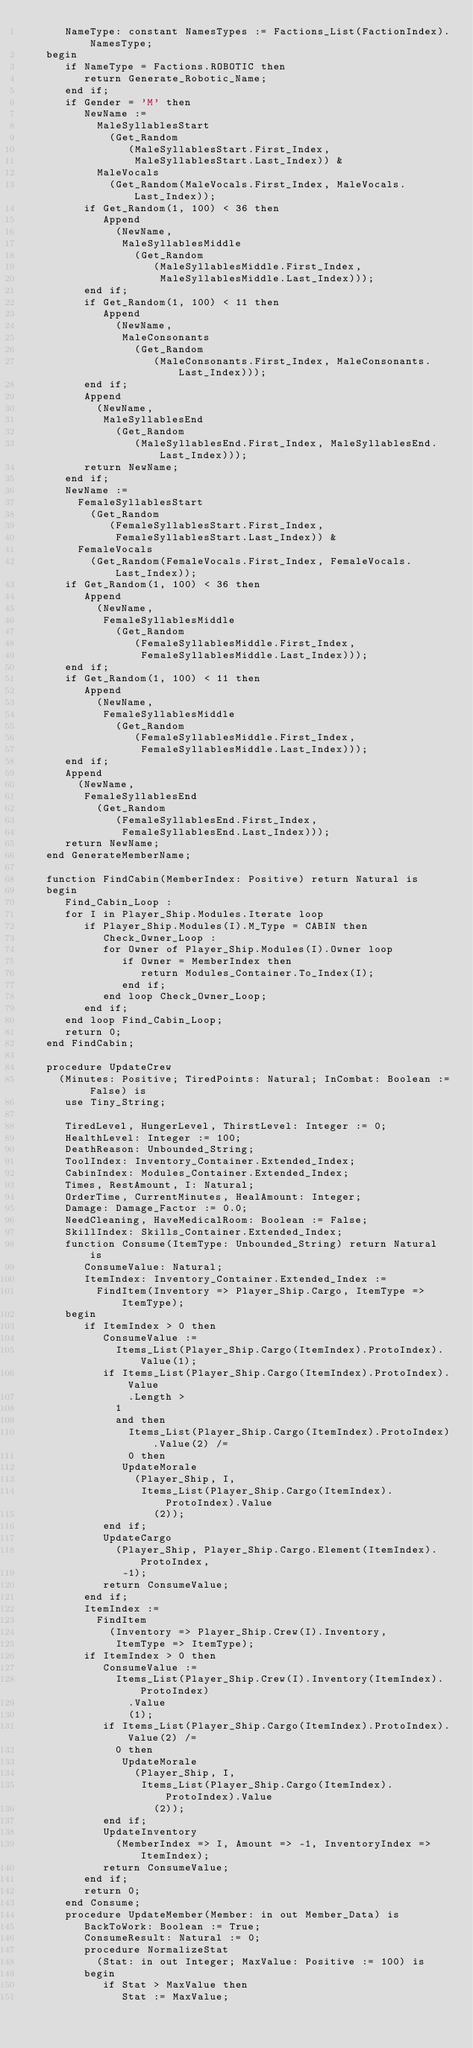Convert code to text. <code><loc_0><loc_0><loc_500><loc_500><_Ada_>      NameType: constant NamesTypes := Factions_List(FactionIndex).NamesType;
   begin
      if NameType = Factions.ROBOTIC then
         return Generate_Robotic_Name;
      end if;
      if Gender = 'M' then
         NewName :=
           MaleSyllablesStart
             (Get_Random
                (MaleSyllablesStart.First_Index,
                 MaleSyllablesStart.Last_Index)) &
           MaleVocals
             (Get_Random(MaleVocals.First_Index, MaleVocals.Last_Index));
         if Get_Random(1, 100) < 36 then
            Append
              (NewName,
               MaleSyllablesMiddle
                 (Get_Random
                    (MaleSyllablesMiddle.First_Index,
                     MaleSyllablesMiddle.Last_Index)));
         end if;
         if Get_Random(1, 100) < 11 then
            Append
              (NewName,
               MaleConsonants
                 (Get_Random
                    (MaleConsonants.First_Index, MaleConsonants.Last_Index)));
         end if;
         Append
           (NewName,
            MaleSyllablesEnd
              (Get_Random
                 (MaleSyllablesEnd.First_Index, MaleSyllablesEnd.Last_Index)));
         return NewName;
      end if;
      NewName :=
        FemaleSyllablesStart
          (Get_Random
             (FemaleSyllablesStart.First_Index,
              FemaleSyllablesStart.Last_Index)) &
        FemaleVocals
          (Get_Random(FemaleVocals.First_Index, FemaleVocals.Last_Index));
      if Get_Random(1, 100) < 36 then
         Append
           (NewName,
            FemaleSyllablesMiddle
              (Get_Random
                 (FemaleSyllablesMiddle.First_Index,
                  FemaleSyllablesMiddle.Last_Index)));
      end if;
      if Get_Random(1, 100) < 11 then
         Append
           (NewName,
            FemaleSyllablesMiddle
              (Get_Random
                 (FemaleSyllablesMiddle.First_Index,
                  FemaleSyllablesMiddle.Last_Index)));
      end if;
      Append
        (NewName,
         FemaleSyllablesEnd
           (Get_Random
              (FemaleSyllablesEnd.First_Index,
               FemaleSyllablesEnd.Last_Index)));
      return NewName;
   end GenerateMemberName;

   function FindCabin(MemberIndex: Positive) return Natural is
   begin
      Find_Cabin_Loop :
      for I in Player_Ship.Modules.Iterate loop
         if Player_Ship.Modules(I).M_Type = CABIN then
            Check_Owner_Loop :
            for Owner of Player_Ship.Modules(I).Owner loop
               if Owner = MemberIndex then
                  return Modules_Container.To_Index(I);
               end if;
            end loop Check_Owner_Loop;
         end if;
      end loop Find_Cabin_Loop;
      return 0;
   end FindCabin;

   procedure UpdateCrew
     (Minutes: Positive; TiredPoints: Natural; InCombat: Boolean := False) is
      use Tiny_String;

      TiredLevel, HungerLevel, ThirstLevel: Integer := 0;
      HealthLevel: Integer := 100;
      DeathReason: Unbounded_String;
      ToolIndex: Inventory_Container.Extended_Index;
      CabinIndex: Modules_Container.Extended_Index;
      Times, RestAmount, I: Natural;
      OrderTime, CurrentMinutes, HealAmount: Integer;
      Damage: Damage_Factor := 0.0;
      NeedCleaning, HaveMedicalRoom: Boolean := False;
      SkillIndex: Skills_Container.Extended_Index;
      function Consume(ItemType: Unbounded_String) return Natural is
         ConsumeValue: Natural;
         ItemIndex: Inventory_Container.Extended_Index :=
           FindItem(Inventory => Player_Ship.Cargo, ItemType => ItemType);
      begin
         if ItemIndex > 0 then
            ConsumeValue :=
              Items_List(Player_Ship.Cargo(ItemIndex).ProtoIndex).Value(1);
            if Items_List(Player_Ship.Cargo(ItemIndex).ProtoIndex).Value
                .Length >
              1
              and then
                Items_List(Player_Ship.Cargo(ItemIndex).ProtoIndex).Value(2) /=
                0 then
               UpdateMorale
                 (Player_Ship, I,
                  Items_List(Player_Ship.Cargo(ItemIndex).ProtoIndex).Value
                    (2));
            end if;
            UpdateCargo
              (Player_Ship, Player_Ship.Cargo.Element(ItemIndex).ProtoIndex,
               -1);
            return ConsumeValue;
         end if;
         ItemIndex :=
           FindItem
             (Inventory => Player_Ship.Crew(I).Inventory,
              ItemType => ItemType);
         if ItemIndex > 0 then
            ConsumeValue :=
              Items_List(Player_Ship.Crew(I).Inventory(ItemIndex).ProtoIndex)
                .Value
                (1);
            if Items_List(Player_Ship.Cargo(ItemIndex).ProtoIndex).Value(2) /=
              0 then
               UpdateMorale
                 (Player_Ship, I,
                  Items_List(Player_Ship.Cargo(ItemIndex).ProtoIndex).Value
                    (2));
            end if;
            UpdateInventory
              (MemberIndex => I, Amount => -1, InventoryIndex => ItemIndex);
            return ConsumeValue;
         end if;
         return 0;
      end Consume;
      procedure UpdateMember(Member: in out Member_Data) is
         BackToWork: Boolean := True;
         ConsumeResult: Natural := 0;
         procedure NormalizeStat
           (Stat: in out Integer; MaxValue: Positive := 100) is
         begin
            if Stat > MaxValue then
               Stat := MaxValue;</code> 